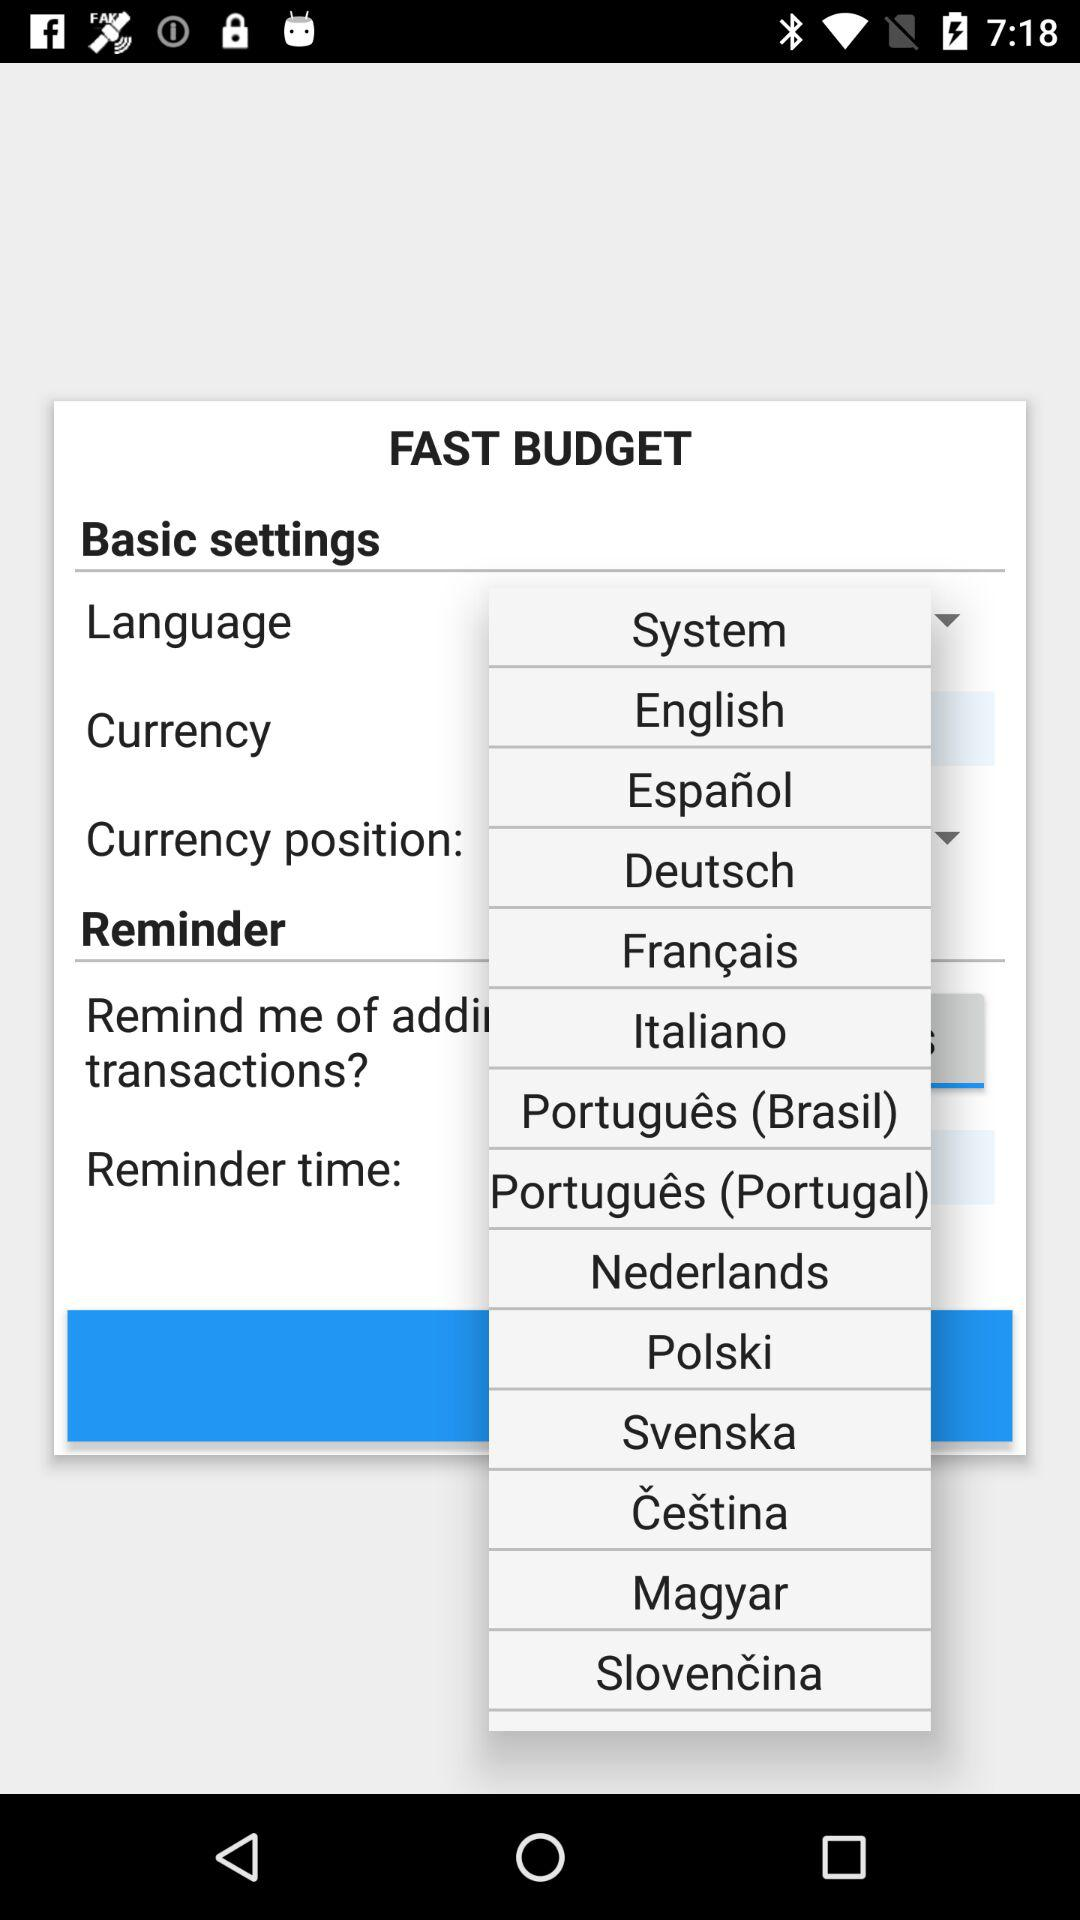Which are the different languages? The different languages are: System, English, Español, Deutsch, Français, Italiano, Português (Brasil), Português (Portugal), Nederlands, Polski, Svenska, Čeština, Magyar and Slovenčina. 